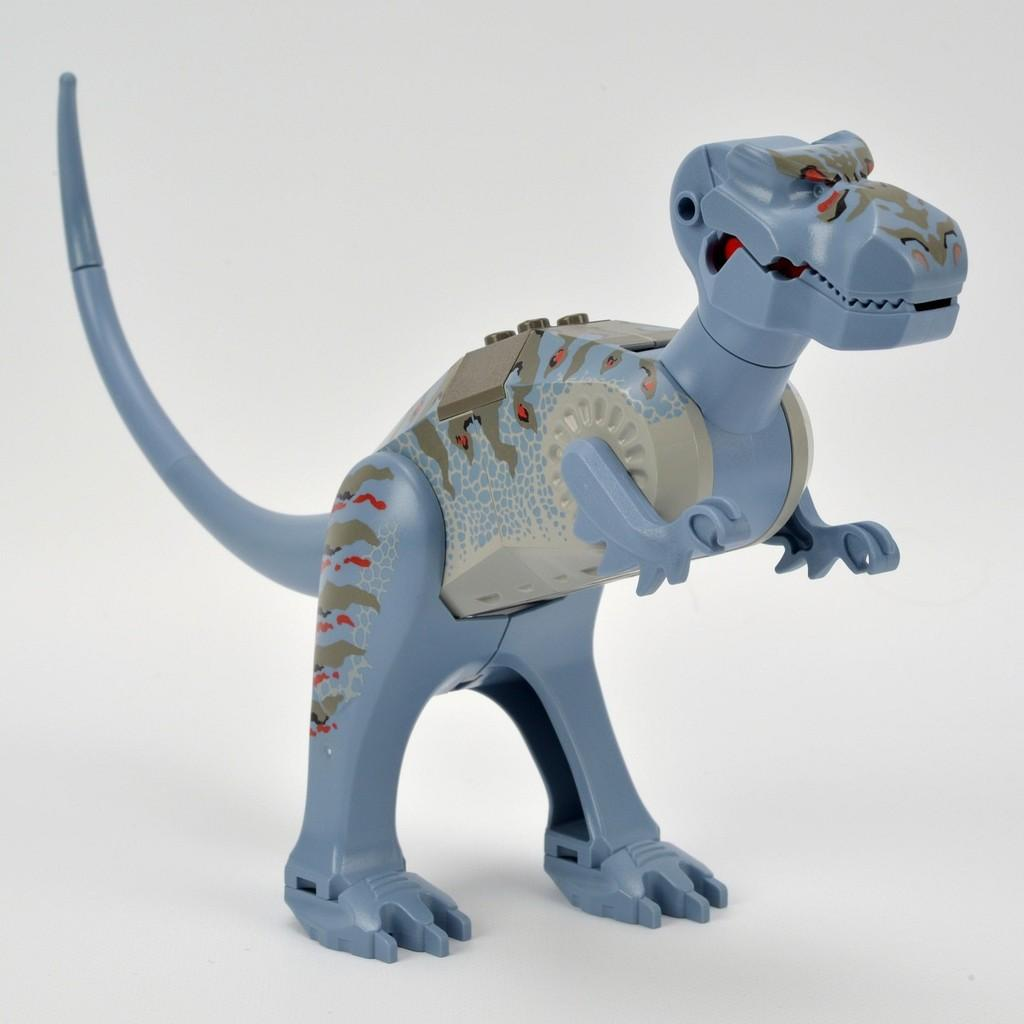What object can be seen in the image? There is a toy in the image. Where is the toy located? The toy is placed on a surface. What type of cherry is sitting on the desk in the image? There is no cherry or desk present in the image; it only features a toy placed on a surface. 